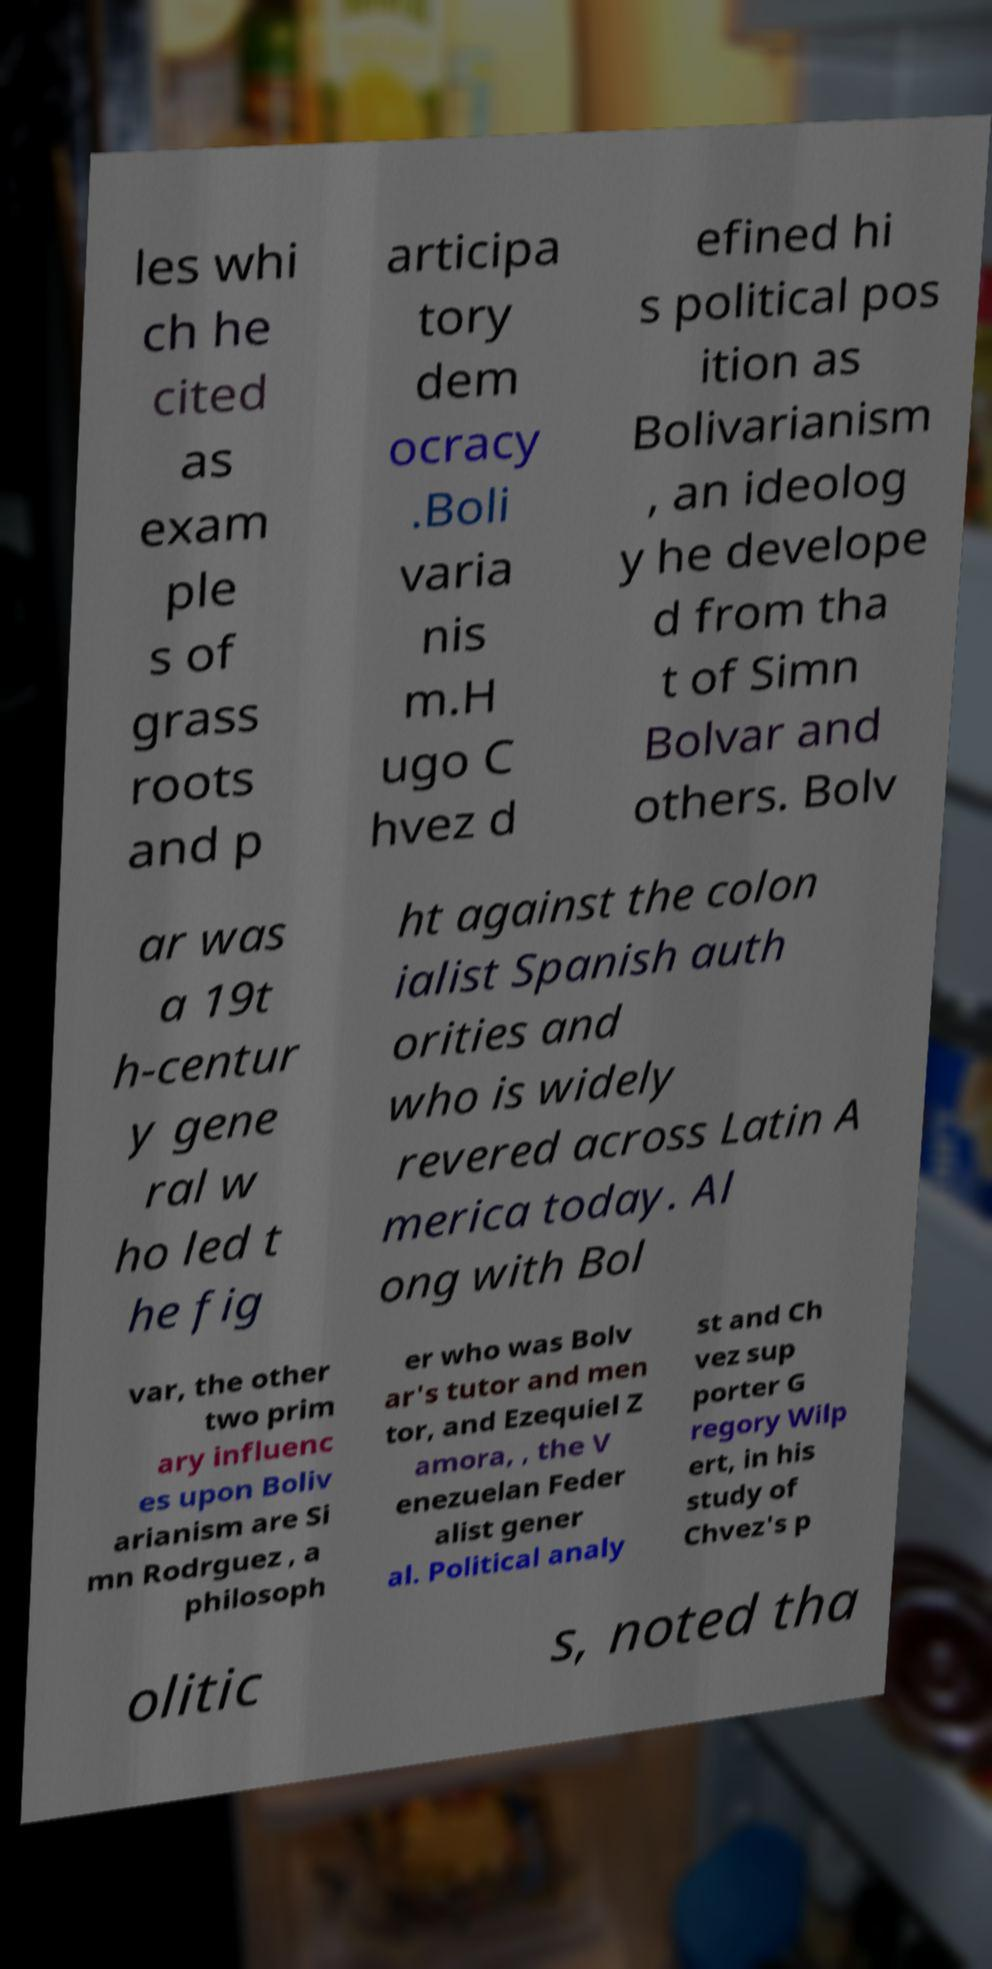What messages or text are displayed in this image? I need them in a readable, typed format. les whi ch he cited as exam ple s of grass roots and p articipa tory dem ocracy .Boli varia nis m.H ugo C hvez d efined hi s political pos ition as Bolivarianism , an ideolog y he develope d from tha t of Simn Bolvar and others. Bolv ar was a 19t h-centur y gene ral w ho led t he fig ht against the colon ialist Spanish auth orities and who is widely revered across Latin A merica today. Al ong with Bol var, the other two prim ary influenc es upon Boliv arianism are Si mn Rodrguez , a philosoph er who was Bolv ar's tutor and men tor, and Ezequiel Z amora, , the V enezuelan Feder alist gener al. Political analy st and Ch vez sup porter G regory Wilp ert, in his study of Chvez's p olitic s, noted tha 